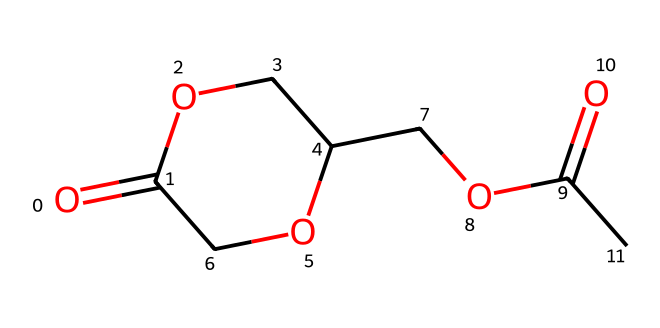What is the molecular formula of the compound? By analyzing the chemical structure from the SMILES representation, you can count the number of carbon (C), hydrogen (H), and oxygen (O) atoms. The SMILES indicates there are 8 carbon atoms, 12 hydrogen atoms, and 4 oxygen atoms. Thus, the molecular formula is C8H12O4.
Answer: C8H12O4 How many rings are present in the structure? In the given SMILES, the ‘C1’ and ‘C1’ indicate that there is a ring closure occurring, forming a single ring structure in the molecule. Thus, there is one ring present.
Answer: one What type of functional groups are present in this molecule? Analyzing the structure reveals the presence of two ester (O=C-O) groups, indicated by the carbonyl (C=O) adjacent to an ether (O) link, which confirms the presence of ester functional groups in the molecule.
Answer: ester What is the significance of the presence of the ether link in this molecule? The ether link (–O–) facilitates solvation and contributes to the solvent properties by lowering the viscosity and allowing molecular flexibility, which is important for lithium-ion battery electrolytes. Hence, this ether contributes to the solvation ability.
Answer: solvation How does the presence of carbonyl groups affect the reactivity of this compound? The carbonyl groups (C=O) increase the reactivity of this compound by making it more polar, which can participate in various reactions such as nucleophilic attacks. This polarity is significant for its performance as an electrolyte solvent.
Answer: increased reactivity What type of solvent properties might this chemical exhibit? Based on its structure, this molecule can exhibit properties suitable for lithium-ion batteries, such as good ionic conductivity and solvating power due to its ether and ester functional groups, which help in facilitating lithium-ion transport.
Answer: ionic conductivity How many oxygen atoms are present in the molecule? The SMILES representation shows four oxygen atoms in total, two from ester groups and two from ether groups, confirming the count of oxygen atoms.
Answer: four 